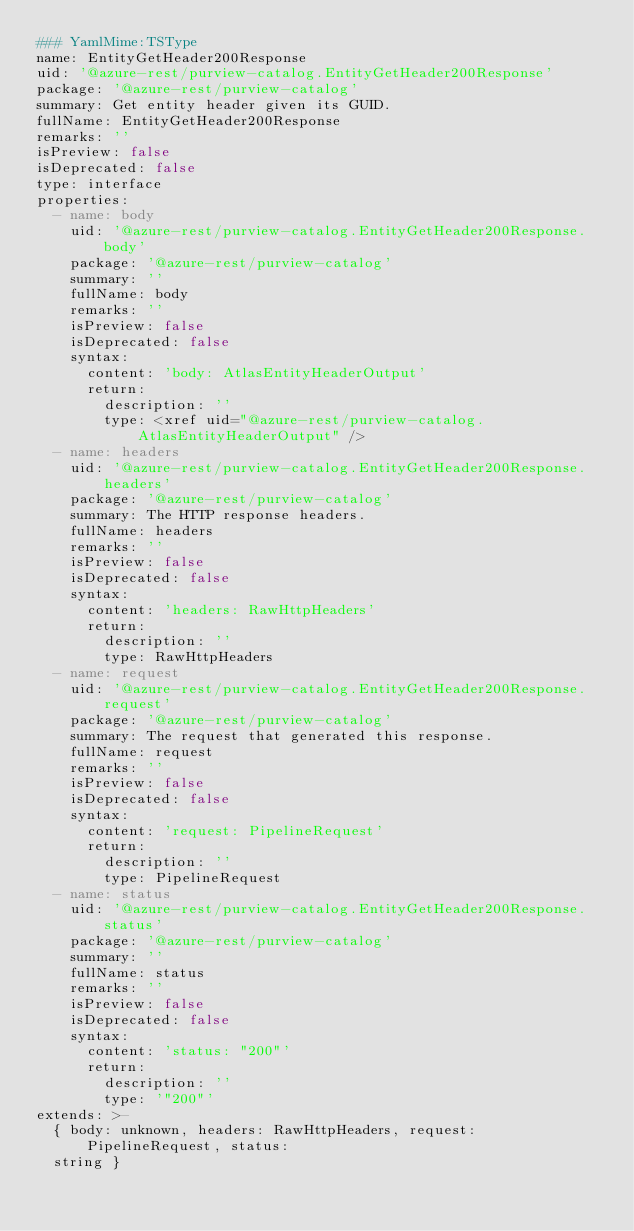Convert code to text. <code><loc_0><loc_0><loc_500><loc_500><_YAML_>### YamlMime:TSType
name: EntityGetHeader200Response
uid: '@azure-rest/purview-catalog.EntityGetHeader200Response'
package: '@azure-rest/purview-catalog'
summary: Get entity header given its GUID.
fullName: EntityGetHeader200Response
remarks: ''
isPreview: false
isDeprecated: false
type: interface
properties:
  - name: body
    uid: '@azure-rest/purview-catalog.EntityGetHeader200Response.body'
    package: '@azure-rest/purview-catalog'
    summary: ''
    fullName: body
    remarks: ''
    isPreview: false
    isDeprecated: false
    syntax:
      content: 'body: AtlasEntityHeaderOutput'
      return:
        description: ''
        type: <xref uid="@azure-rest/purview-catalog.AtlasEntityHeaderOutput" />
  - name: headers
    uid: '@azure-rest/purview-catalog.EntityGetHeader200Response.headers'
    package: '@azure-rest/purview-catalog'
    summary: The HTTP response headers.
    fullName: headers
    remarks: ''
    isPreview: false
    isDeprecated: false
    syntax:
      content: 'headers: RawHttpHeaders'
      return:
        description: ''
        type: RawHttpHeaders
  - name: request
    uid: '@azure-rest/purview-catalog.EntityGetHeader200Response.request'
    package: '@azure-rest/purview-catalog'
    summary: The request that generated this response.
    fullName: request
    remarks: ''
    isPreview: false
    isDeprecated: false
    syntax:
      content: 'request: PipelineRequest'
      return:
        description: ''
        type: PipelineRequest
  - name: status
    uid: '@azure-rest/purview-catalog.EntityGetHeader200Response.status'
    package: '@azure-rest/purview-catalog'
    summary: ''
    fullName: status
    remarks: ''
    isPreview: false
    isDeprecated: false
    syntax:
      content: 'status: "200"'
      return:
        description: ''
        type: '"200"'
extends: >-
  { body: unknown, headers: RawHttpHeaders, request: PipelineRequest, status:
  string }
</code> 